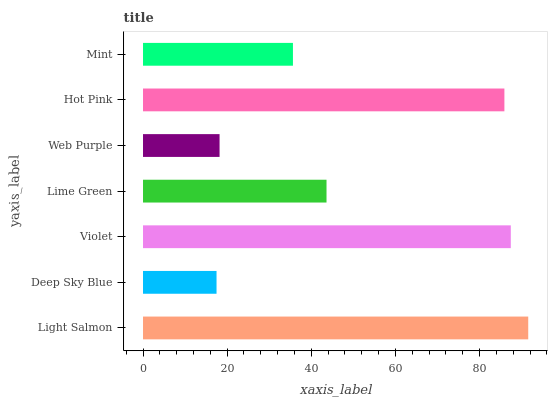Is Deep Sky Blue the minimum?
Answer yes or no. Yes. Is Light Salmon the maximum?
Answer yes or no. Yes. Is Violet the minimum?
Answer yes or no. No. Is Violet the maximum?
Answer yes or no. No. Is Violet greater than Deep Sky Blue?
Answer yes or no. Yes. Is Deep Sky Blue less than Violet?
Answer yes or no. Yes. Is Deep Sky Blue greater than Violet?
Answer yes or no. No. Is Violet less than Deep Sky Blue?
Answer yes or no. No. Is Lime Green the high median?
Answer yes or no. Yes. Is Lime Green the low median?
Answer yes or no. Yes. Is Violet the high median?
Answer yes or no. No. Is Deep Sky Blue the low median?
Answer yes or no. No. 